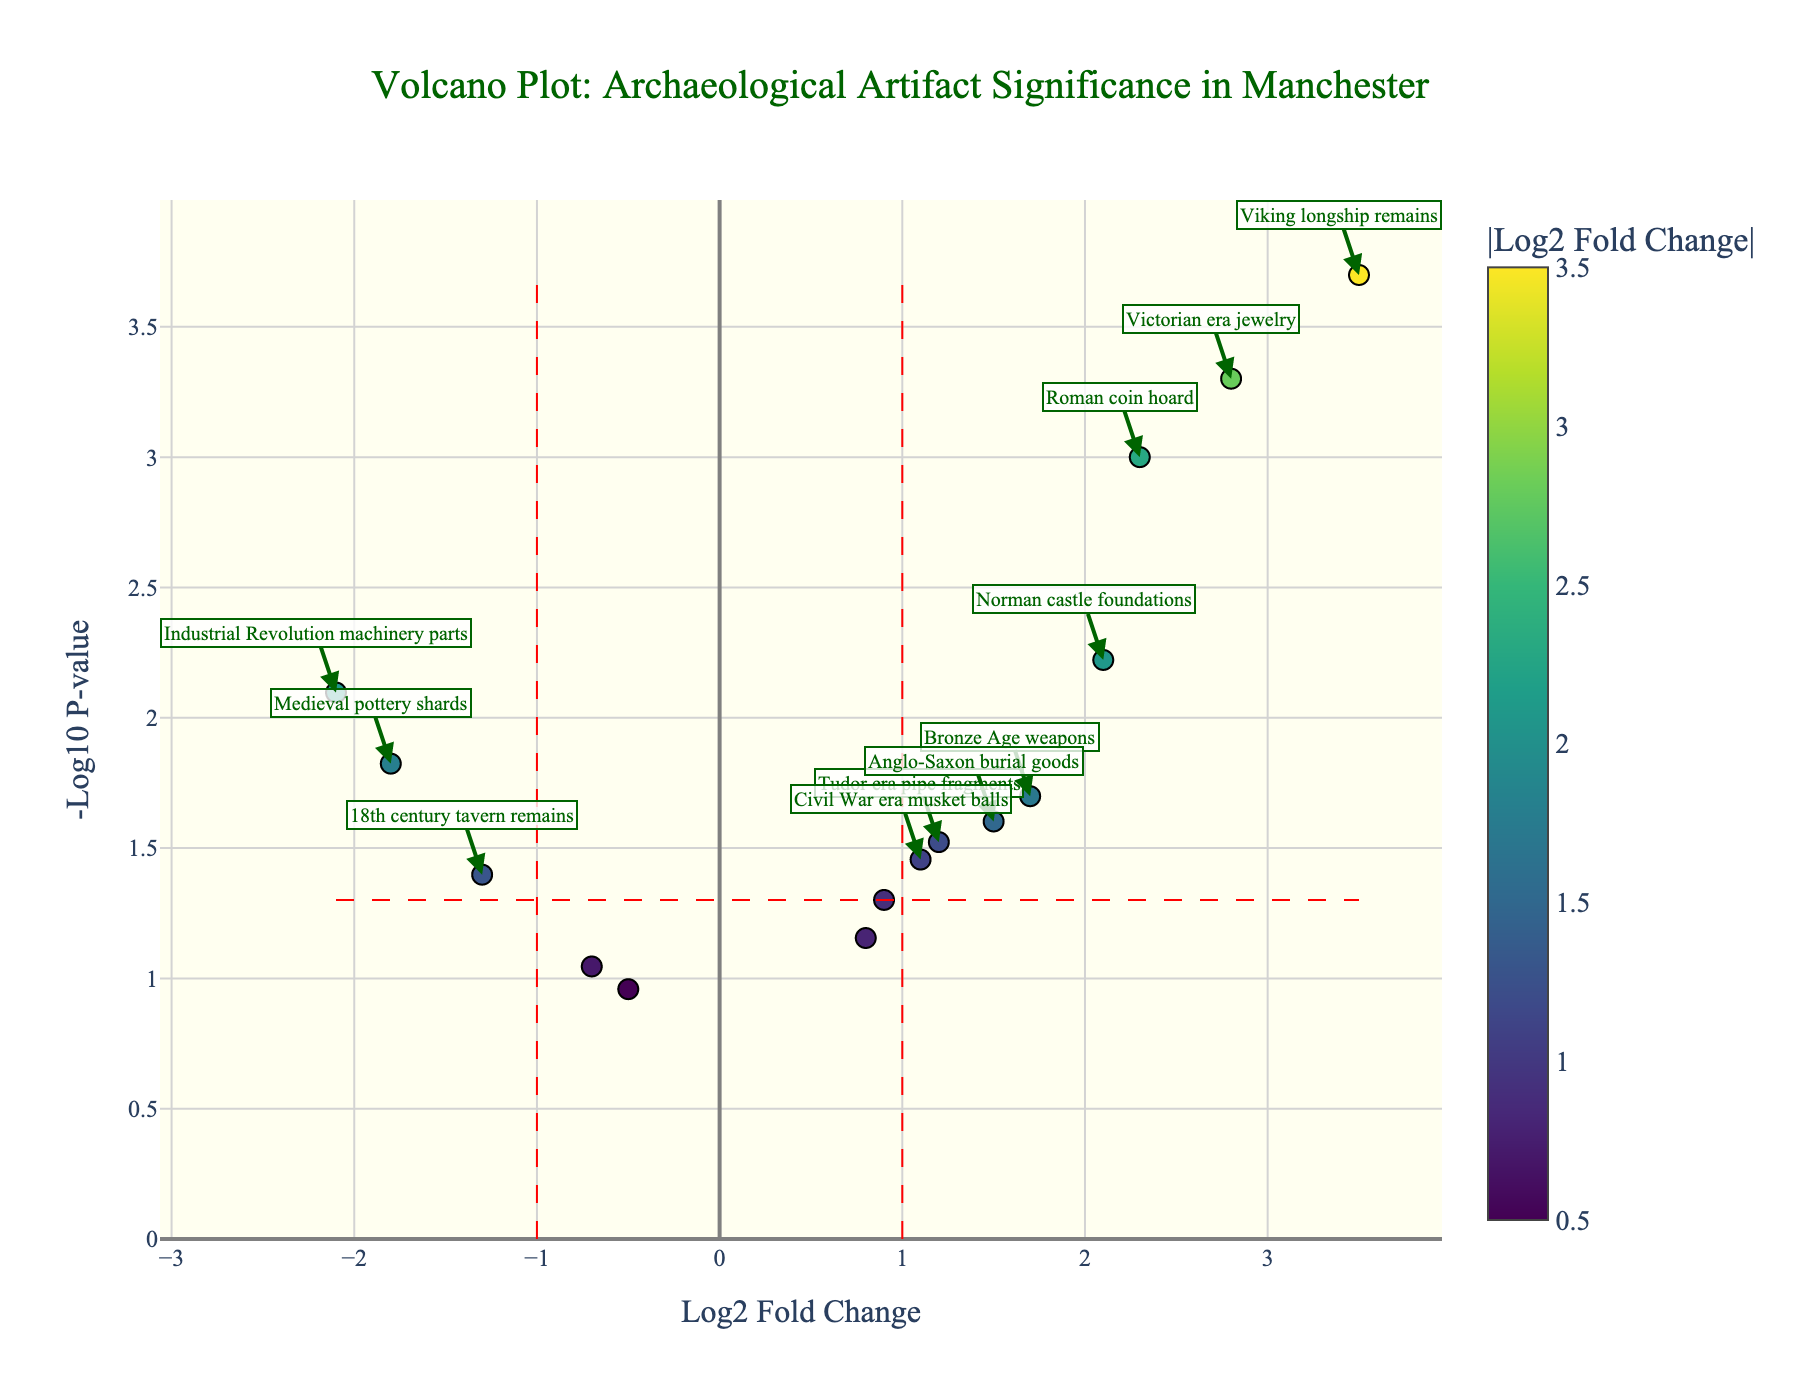what does the title of the plot indicate? The title of the plot indicates that it is a Volcano Plot analyzing the significance of archaeological artifacts from various excavation sites in Manchester. This suggests that the plot is used to compare the significance (based on p-value and fold change) of different artifact discoveries in Manchester.
Answer: A Volcano Plot: Archaeological Artifact Significance in Manchester what do the axes represent? The x-axis represents the Log2 Fold Change in artifact frequency, and the y-axis represents the negative Log10 of the p-value.
Answer: x-axis: Log2 Fold Change, y-axis: -Log10 P-value how many artifacts have a log2 fold change greater than 2? By examining the plot, we count the data points that fall to the right of the vertical line at Log2 Fold Change = 2. This includes data points labeled such as the "Roman coin hoard," "Victorian era jewelry," "Viking longship remains," and "Norman castle foundations."
Answer: 4 artifacts which artifact has the highest -log10 p-value? The artifact with the highest -log10 p-value is the one that appears highest on the y-axis in the plot. By checking the plot, this is the "Viking longship remains."
Answer: Viking longship remains what is the log2 fold change and p-value of the Industrial Revolution machinery parts? By referring to the hover text or annotations in the plot, the log2 fold change for the Industrial Revolution machinery parts is -2.1, and its p-value is 0.008.
Answer: -2.1, 0.008 which artifact has the most significant increase in frequency compared to the others? The artifact with the most significant increase in frequency will have the highest positive log2 fold change and a low p-value, making it stand out in the upper right portion of the plot. This is the "Viking longship remains" with a log2 fold change of 3.5 and a p-value of 0.0002.
Answer: Viking longship remains how many artifacts have a p-value less than 0.01? Artifacts with p-values less than 0.01 will be above the horizontal threshold line. By counting the data points above this line in the plot, we find artifacts such as "Roman coin hoard," "Viking longship remains," "Victorian era jewelry," "Industrial Revolution machinery parts," and "Norman castle foundations."
Answer: 5 artifacts which artifact has the lowest decrease in frequency, and what are its values? The lowest decrease in frequency would be the artifact with the smallest negative log2 fold change, among those with significant p-values. By examining the plot, "Medieval pottery shards" has the smallest negative log2 fold change of -1.8 and a p-value of 0.015.
Answer: Medieval pottery shards, -1.8 log2 fold change, 0.015 p-value 